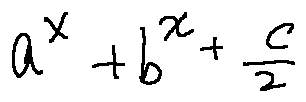<formula> <loc_0><loc_0><loc_500><loc_500>a ^ { x } + b ^ { x } + \frac { c } { 2 }</formula> 